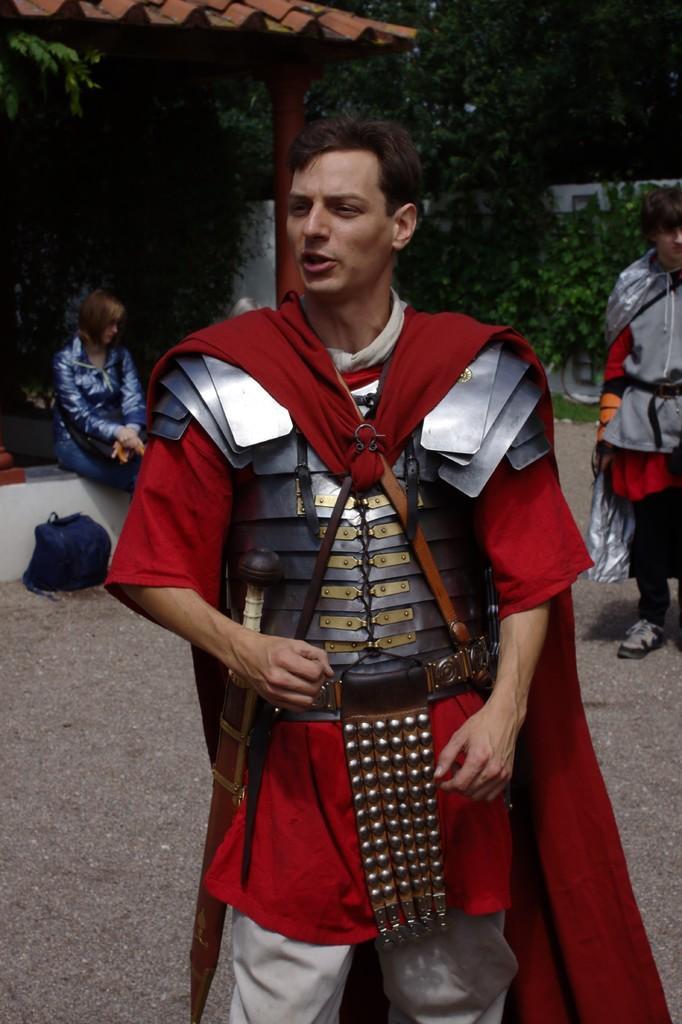Please provide a concise description of this image. In this picture I can see few people are standing on the ground with different costume, behind we can see a woman sitting under the roof, around we can see some trees. 